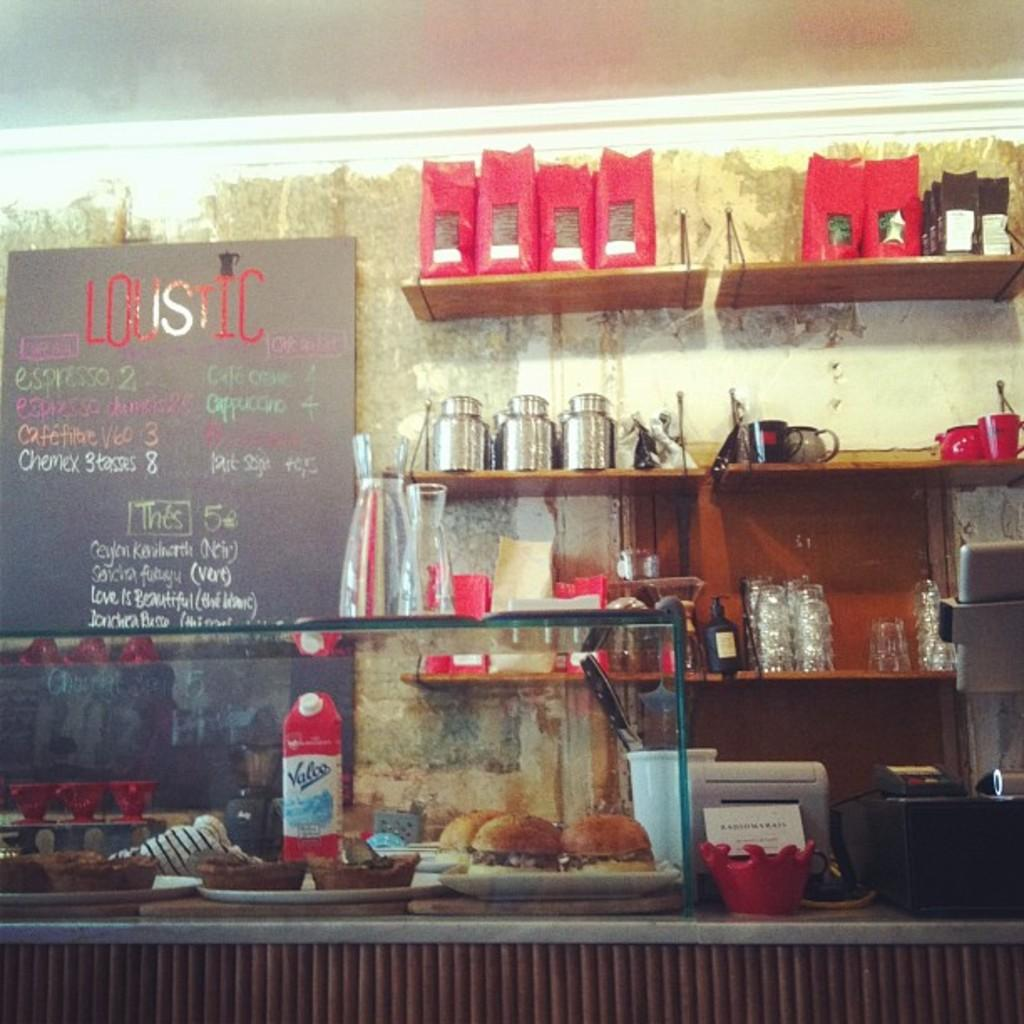<image>
Share a concise interpretation of the image provided. Store front that says "Loustic" in red on a sign. 